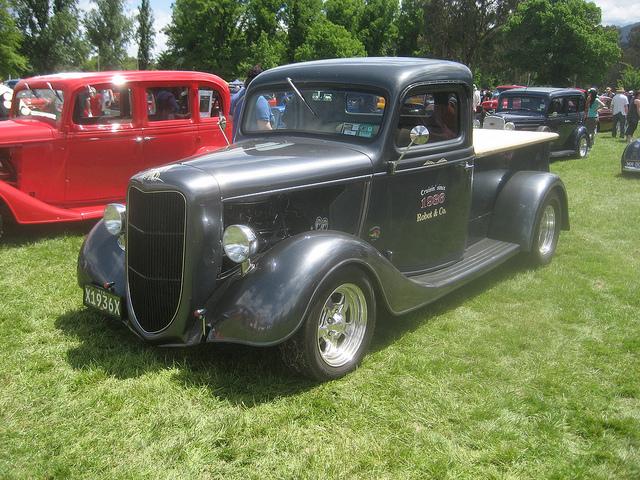Are the vehicles all the same color?
Quick response, please. No. How many vehicles are in the picture?
Concise answer only. 3. Is this a modern day vehicle?
Give a very brief answer. No. 